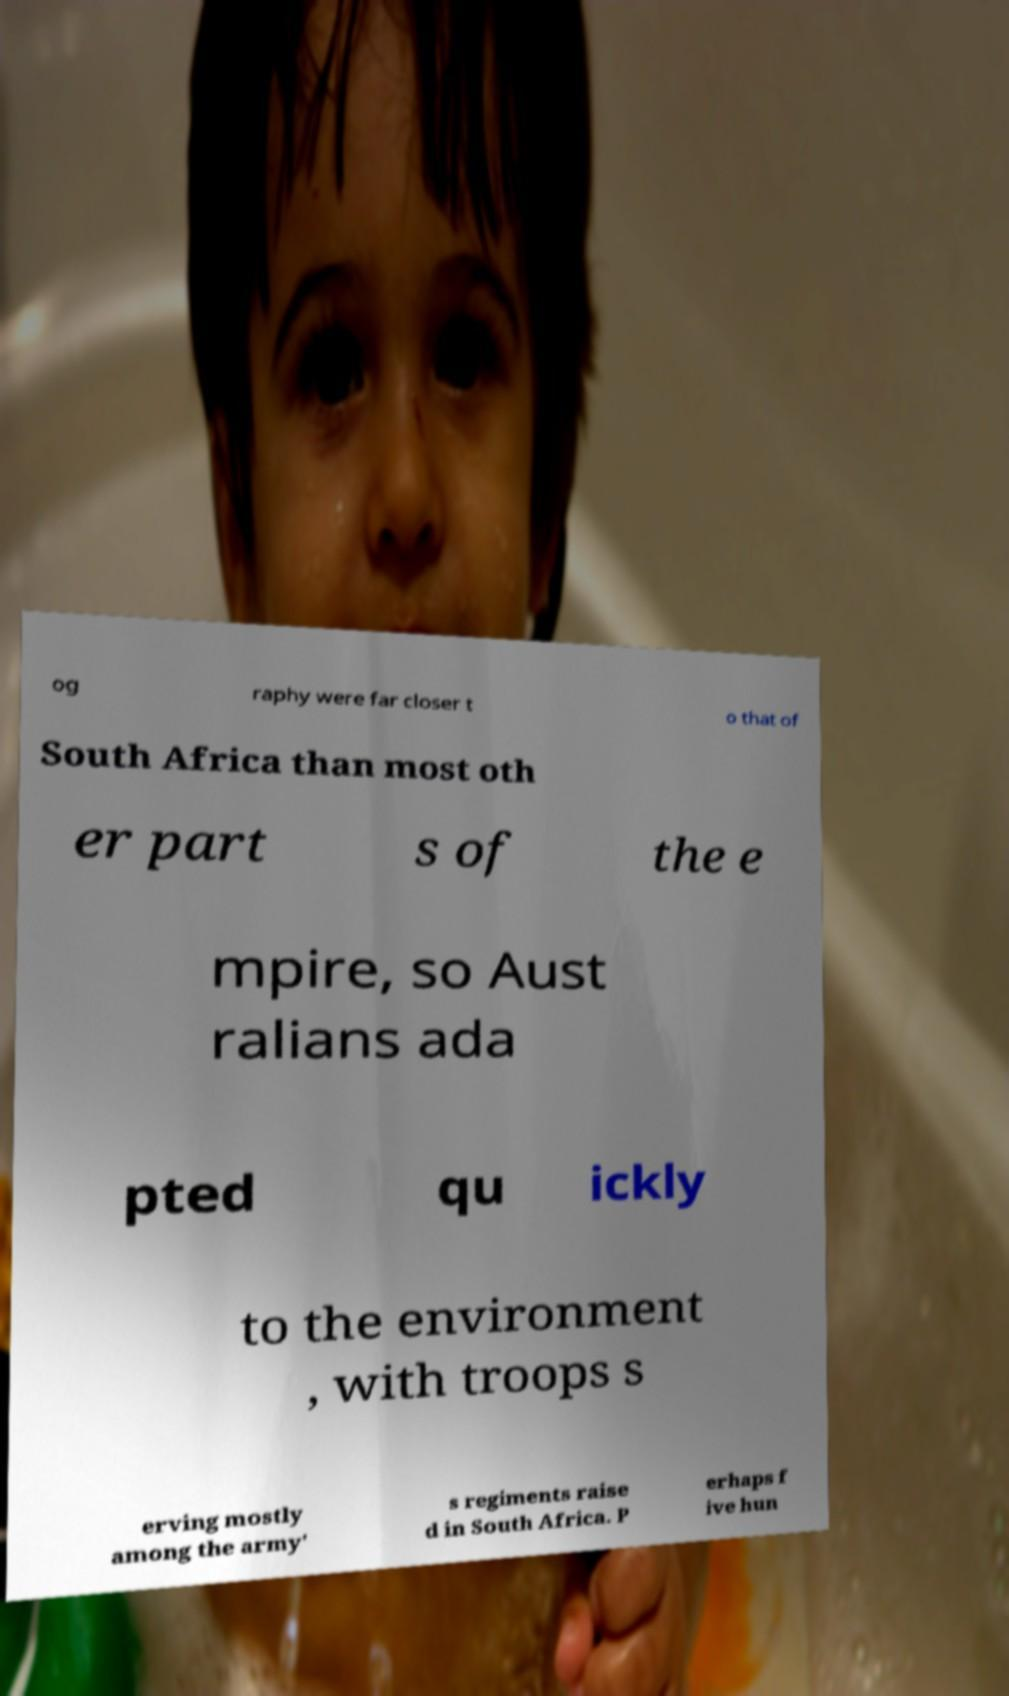Please read and relay the text visible in this image. What does it say? og raphy were far closer t o that of South Africa than most oth er part s of the e mpire, so Aust ralians ada pted qu ickly to the environment , with troops s erving mostly among the army' s regiments raise d in South Africa. P erhaps f ive hun 